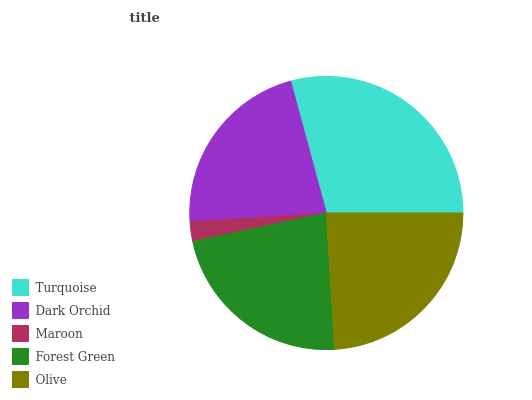Is Maroon the minimum?
Answer yes or no. Yes. Is Turquoise the maximum?
Answer yes or no. Yes. Is Dark Orchid the minimum?
Answer yes or no. No. Is Dark Orchid the maximum?
Answer yes or no. No. Is Turquoise greater than Dark Orchid?
Answer yes or no. Yes. Is Dark Orchid less than Turquoise?
Answer yes or no. Yes. Is Dark Orchid greater than Turquoise?
Answer yes or no. No. Is Turquoise less than Dark Orchid?
Answer yes or no. No. Is Forest Green the high median?
Answer yes or no. Yes. Is Forest Green the low median?
Answer yes or no. Yes. Is Olive the high median?
Answer yes or no. No. Is Maroon the low median?
Answer yes or no. No. 